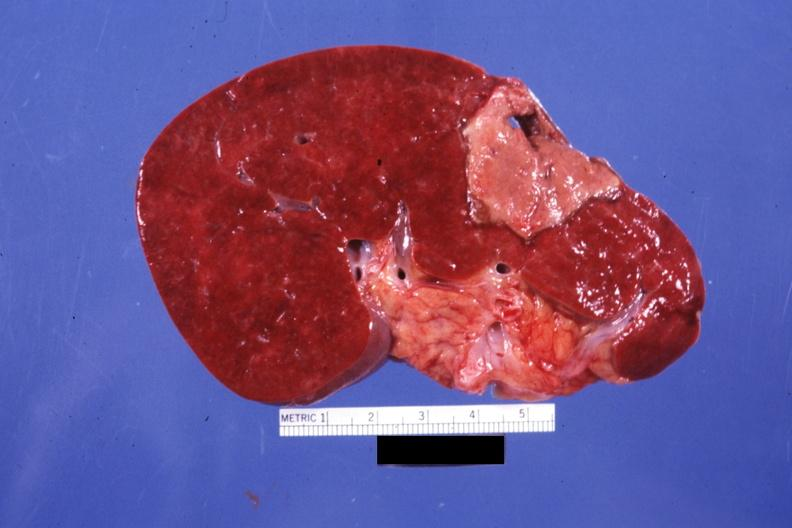s hematologic present?
Answer the question using a single word or phrase. Yes 